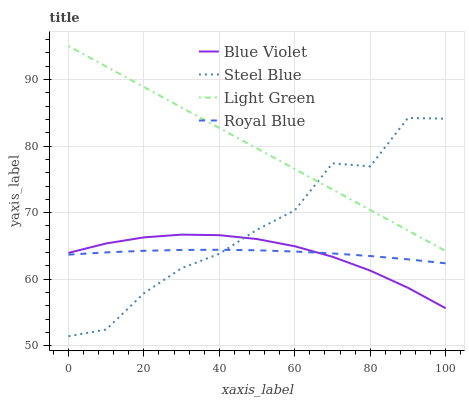Does Steel Blue have the minimum area under the curve?
Answer yes or no. No. Does Steel Blue have the maximum area under the curve?
Answer yes or no. No. Is Steel Blue the smoothest?
Answer yes or no. No. Is Light Green the roughest?
Answer yes or no. No. Does Light Green have the lowest value?
Answer yes or no. No. Does Steel Blue have the highest value?
Answer yes or no. No. Is Blue Violet less than Light Green?
Answer yes or no. Yes. Is Light Green greater than Royal Blue?
Answer yes or no. Yes. Does Blue Violet intersect Light Green?
Answer yes or no. No. 